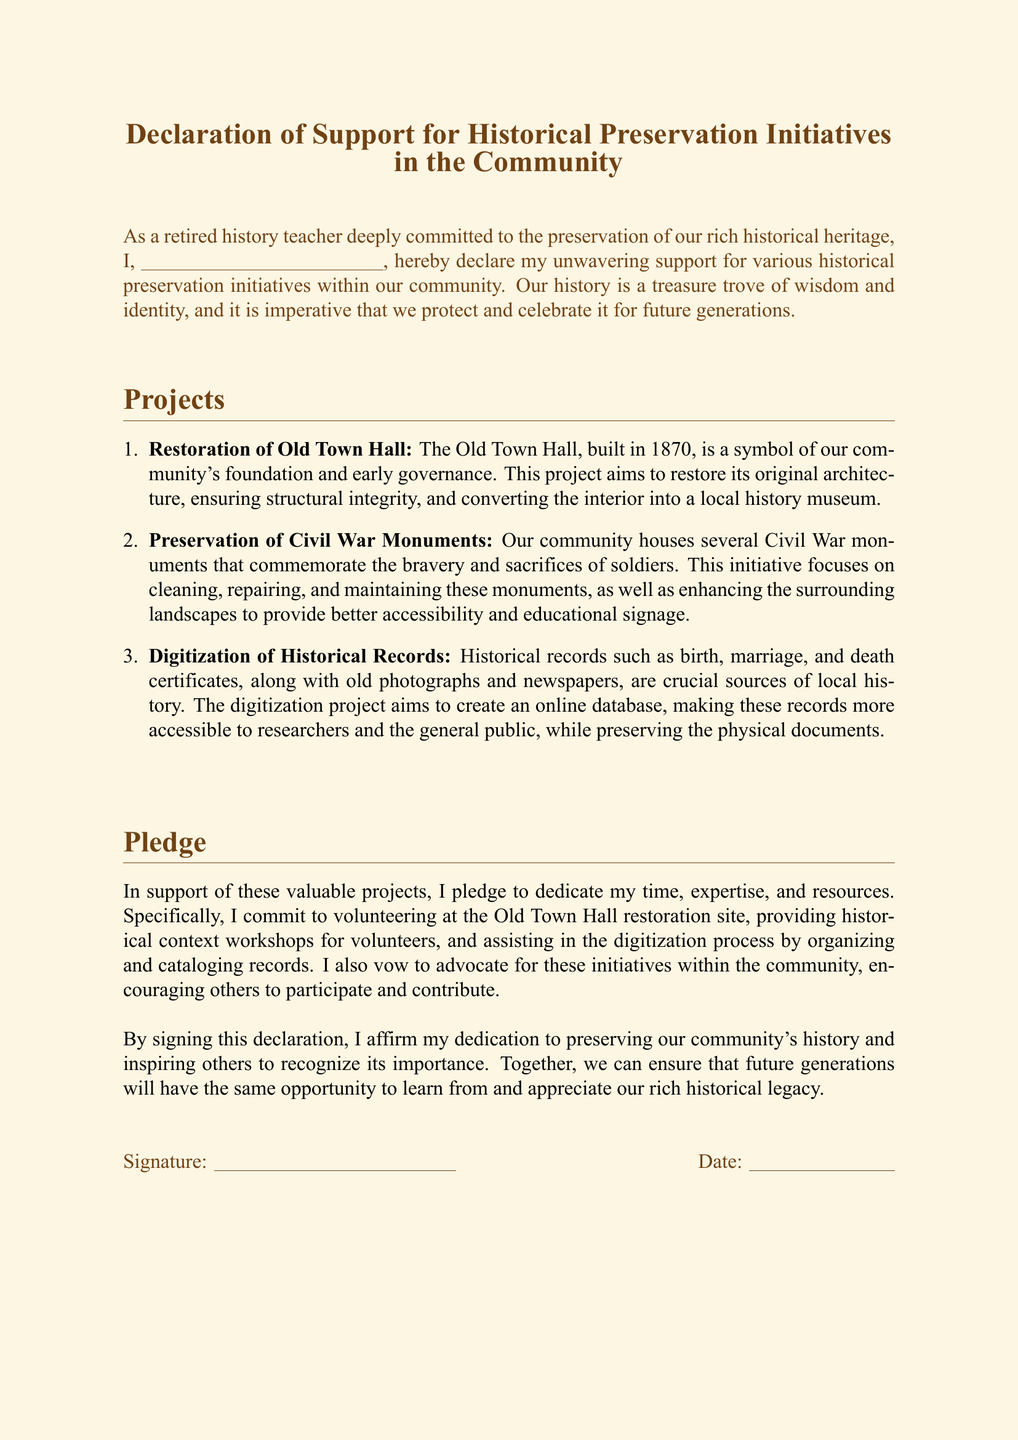What is the title of the document? The title is prominently displayed at the top of the document, indicating its focus on community historical preservation initiatives.
Answer: Declaration of Support for Historical Preservation Initiatives in the Community Who is the intended signer? The document reflects the identity of the individual making the declaration as a retired history teacher.
Answer: a retired history teacher When was the Old Town Hall built? The document provides the year the building was constructed, which is significant for historical context.
Answer: 1870 What is one of the projects mentioned? The document lists several projects aimed at preservation; mentioning one of them reflects the initiatives being supported.
Answer: Restoration of Old Town Hall What is pledged in support of the projects? The signer commits to specific actions to help with the historical initiatives outlined in the document.
Answer: dedicate my time, expertise, and resources What is the purpose of the digitization project? The document describes the goal of this initiative, which enhances public access to local history through technology.
Answer: create an online database What does the signer vow to do within the community? The signer expresses a larger commitment that extends beyond personal involvement, aiming to inspire communal participation.
Answer: advocate for these initiatives How does the signer feel about the community's history? The document conveys a strong sentiment regarding the importance of historical preservation as articulated by the signer.
Answer: deeply committed to the preservation What type of document is this? The format and content of the text indicate its nature and intent clearly, categorizing it for specific purposes.
Answer: signed Declaration 